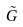Convert formula to latex. <formula><loc_0><loc_0><loc_500><loc_500>\tilde { G }</formula> 